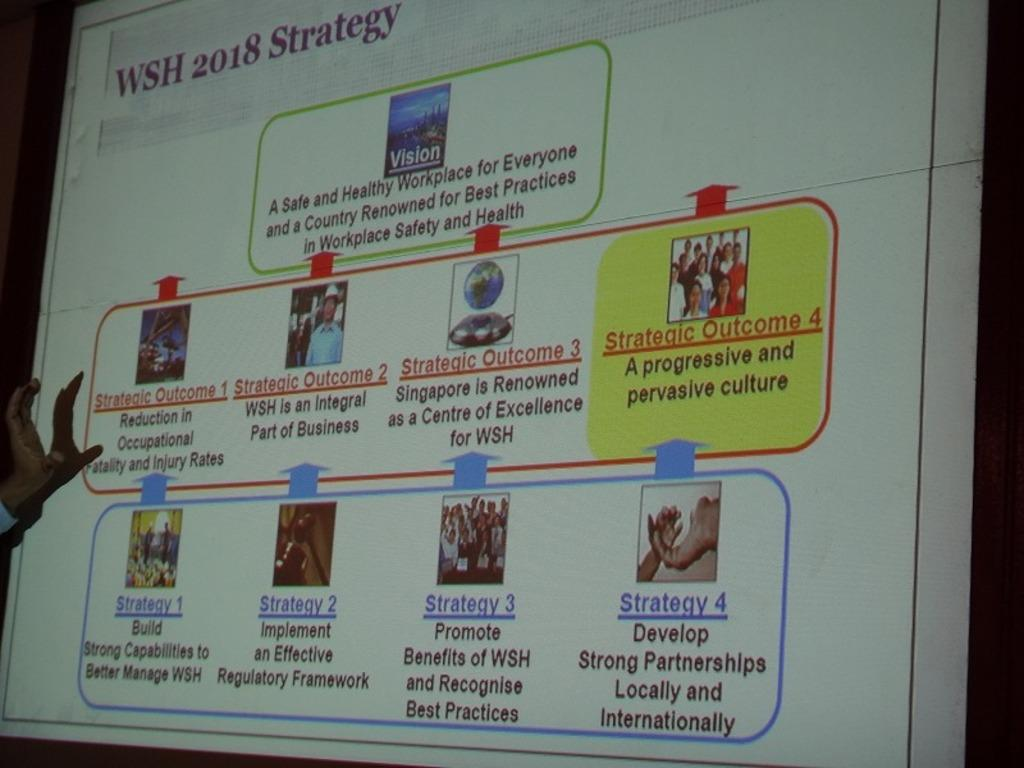<image>
Write a terse but informative summary of the picture. Projector screen with the words WSH 2018 Strategy along the top 